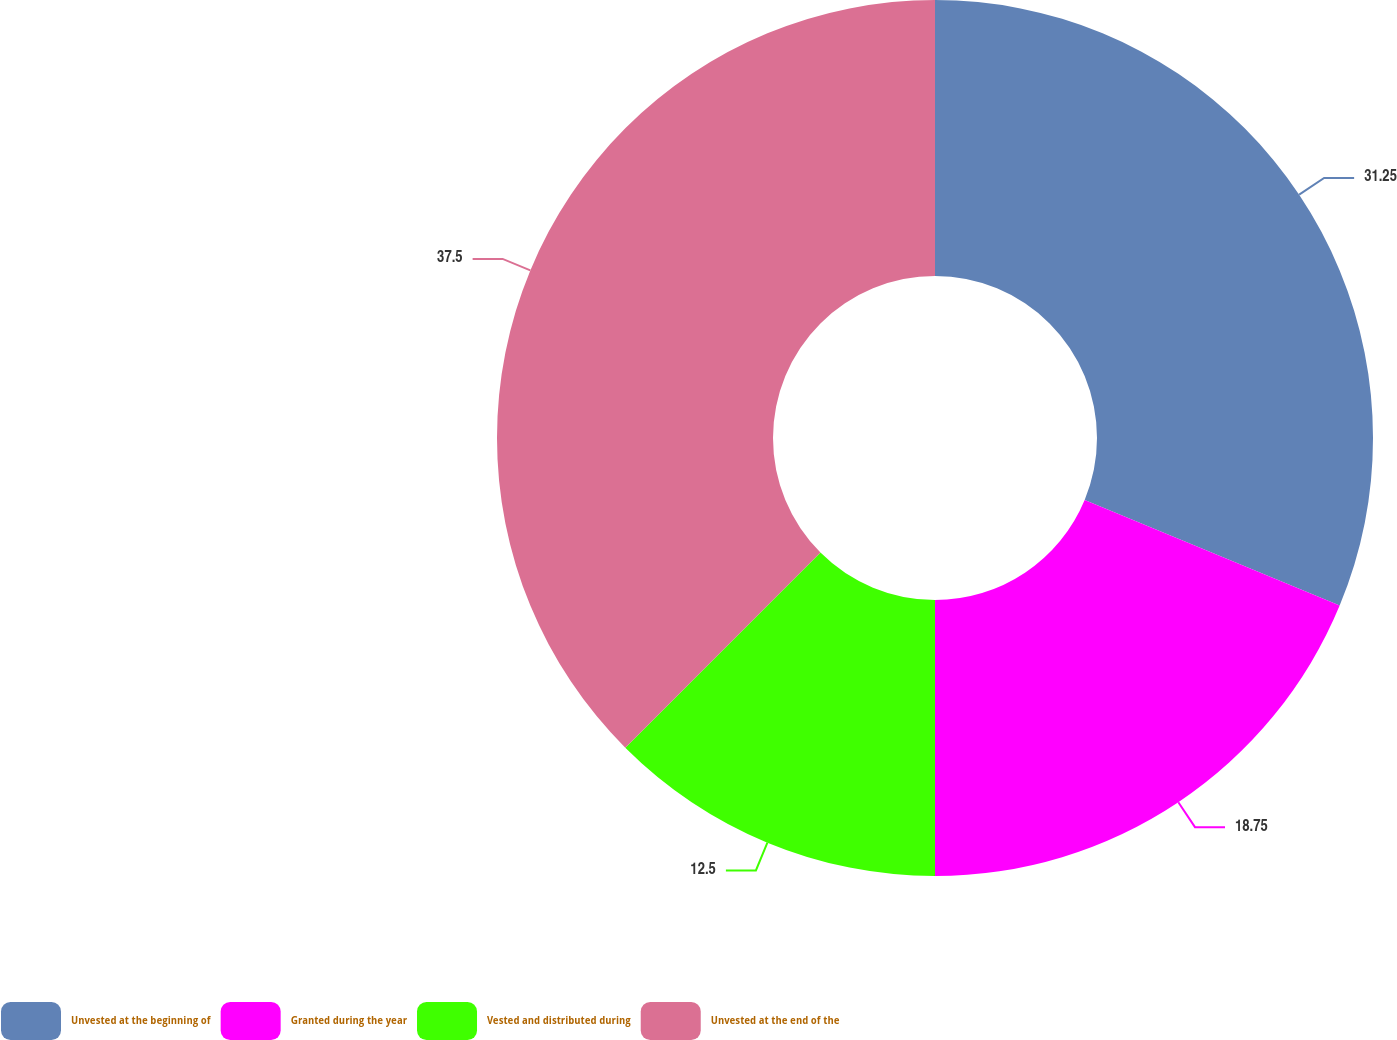Convert chart to OTSL. <chart><loc_0><loc_0><loc_500><loc_500><pie_chart><fcel>Unvested at the beginning of<fcel>Granted during the year<fcel>Vested and distributed during<fcel>Unvested at the end of the<nl><fcel>31.25%<fcel>18.75%<fcel>12.5%<fcel>37.5%<nl></chart> 